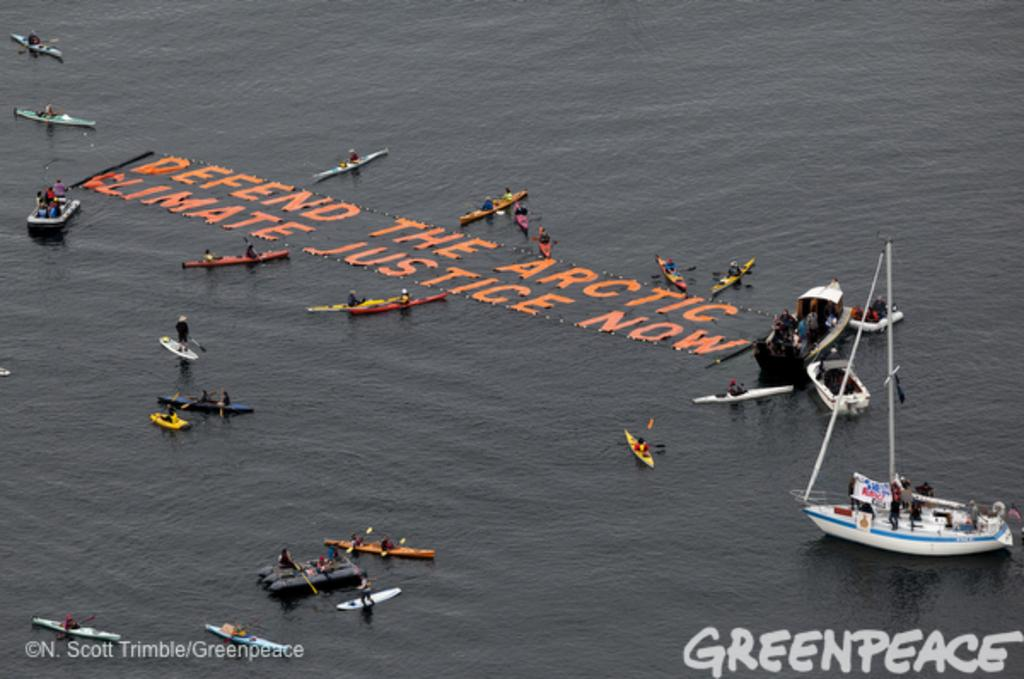What is written or depicted above the water in the image? There are letters visible above the water. What type of vehicles can be seen in the image? There are boats in the image. Are there any human figures present in the image? Yes, there are people in the image. What can be seen at the bottom of the image? Watermarks are present at the bottom of the image. How many clovers can be seen growing near the water in the image? There are no clovers present in the image; it features letters, boats, people, and watermarks. What type of club is visible in the image? There is no club present in the image. 